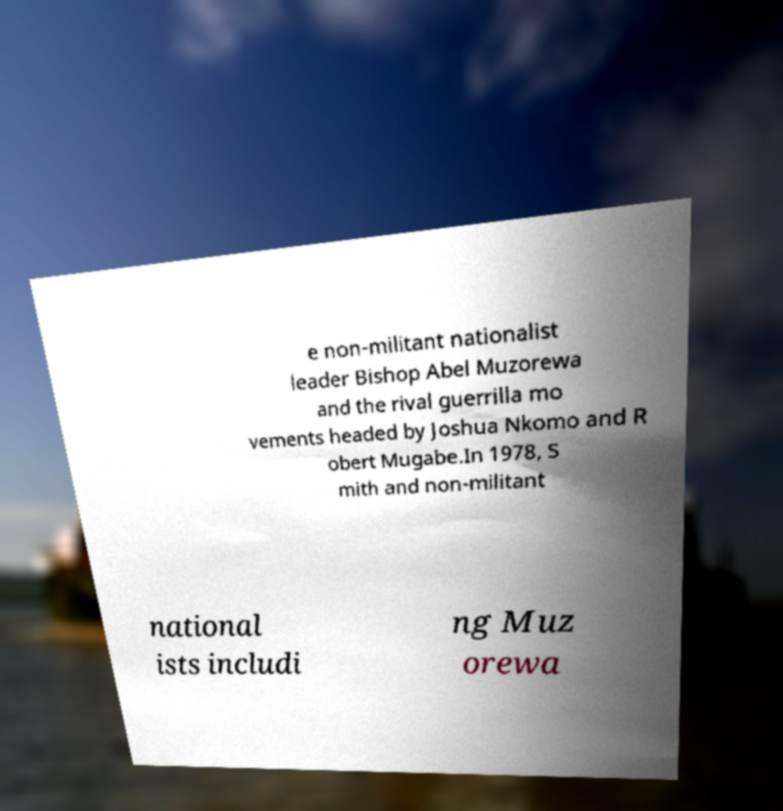I need the written content from this picture converted into text. Can you do that? e non-militant nationalist leader Bishop Abel Muzorewa and the rival guerrilla mo vements headed by Joshua Nkomo and R obert Mugabe.In 1978, S mith and non-militant national ists includi ng Muz orewa 